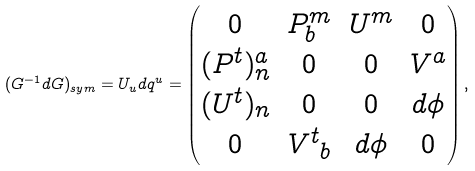<formula> <loc_0><loc_0><loc_500><loc_500>( G ^ { - 1 } d G ) _ { s y m } = U _ { u } d q ^ { u } = \begin{pmatrix} 0 & P ^ { m } _ { b } & U ^ { m } & 0 \\ ( P ^ { t } ) ^ { a } _ { n } & 0 & 0 & V ^ { a } \\ ( { U ^ { t } } ) _ { n } & 0 & 0 & d \phi \\ 0 & { V ^ { t } } _ { b } & d \phi & 0 \end{pmatrix} ,</formula> 